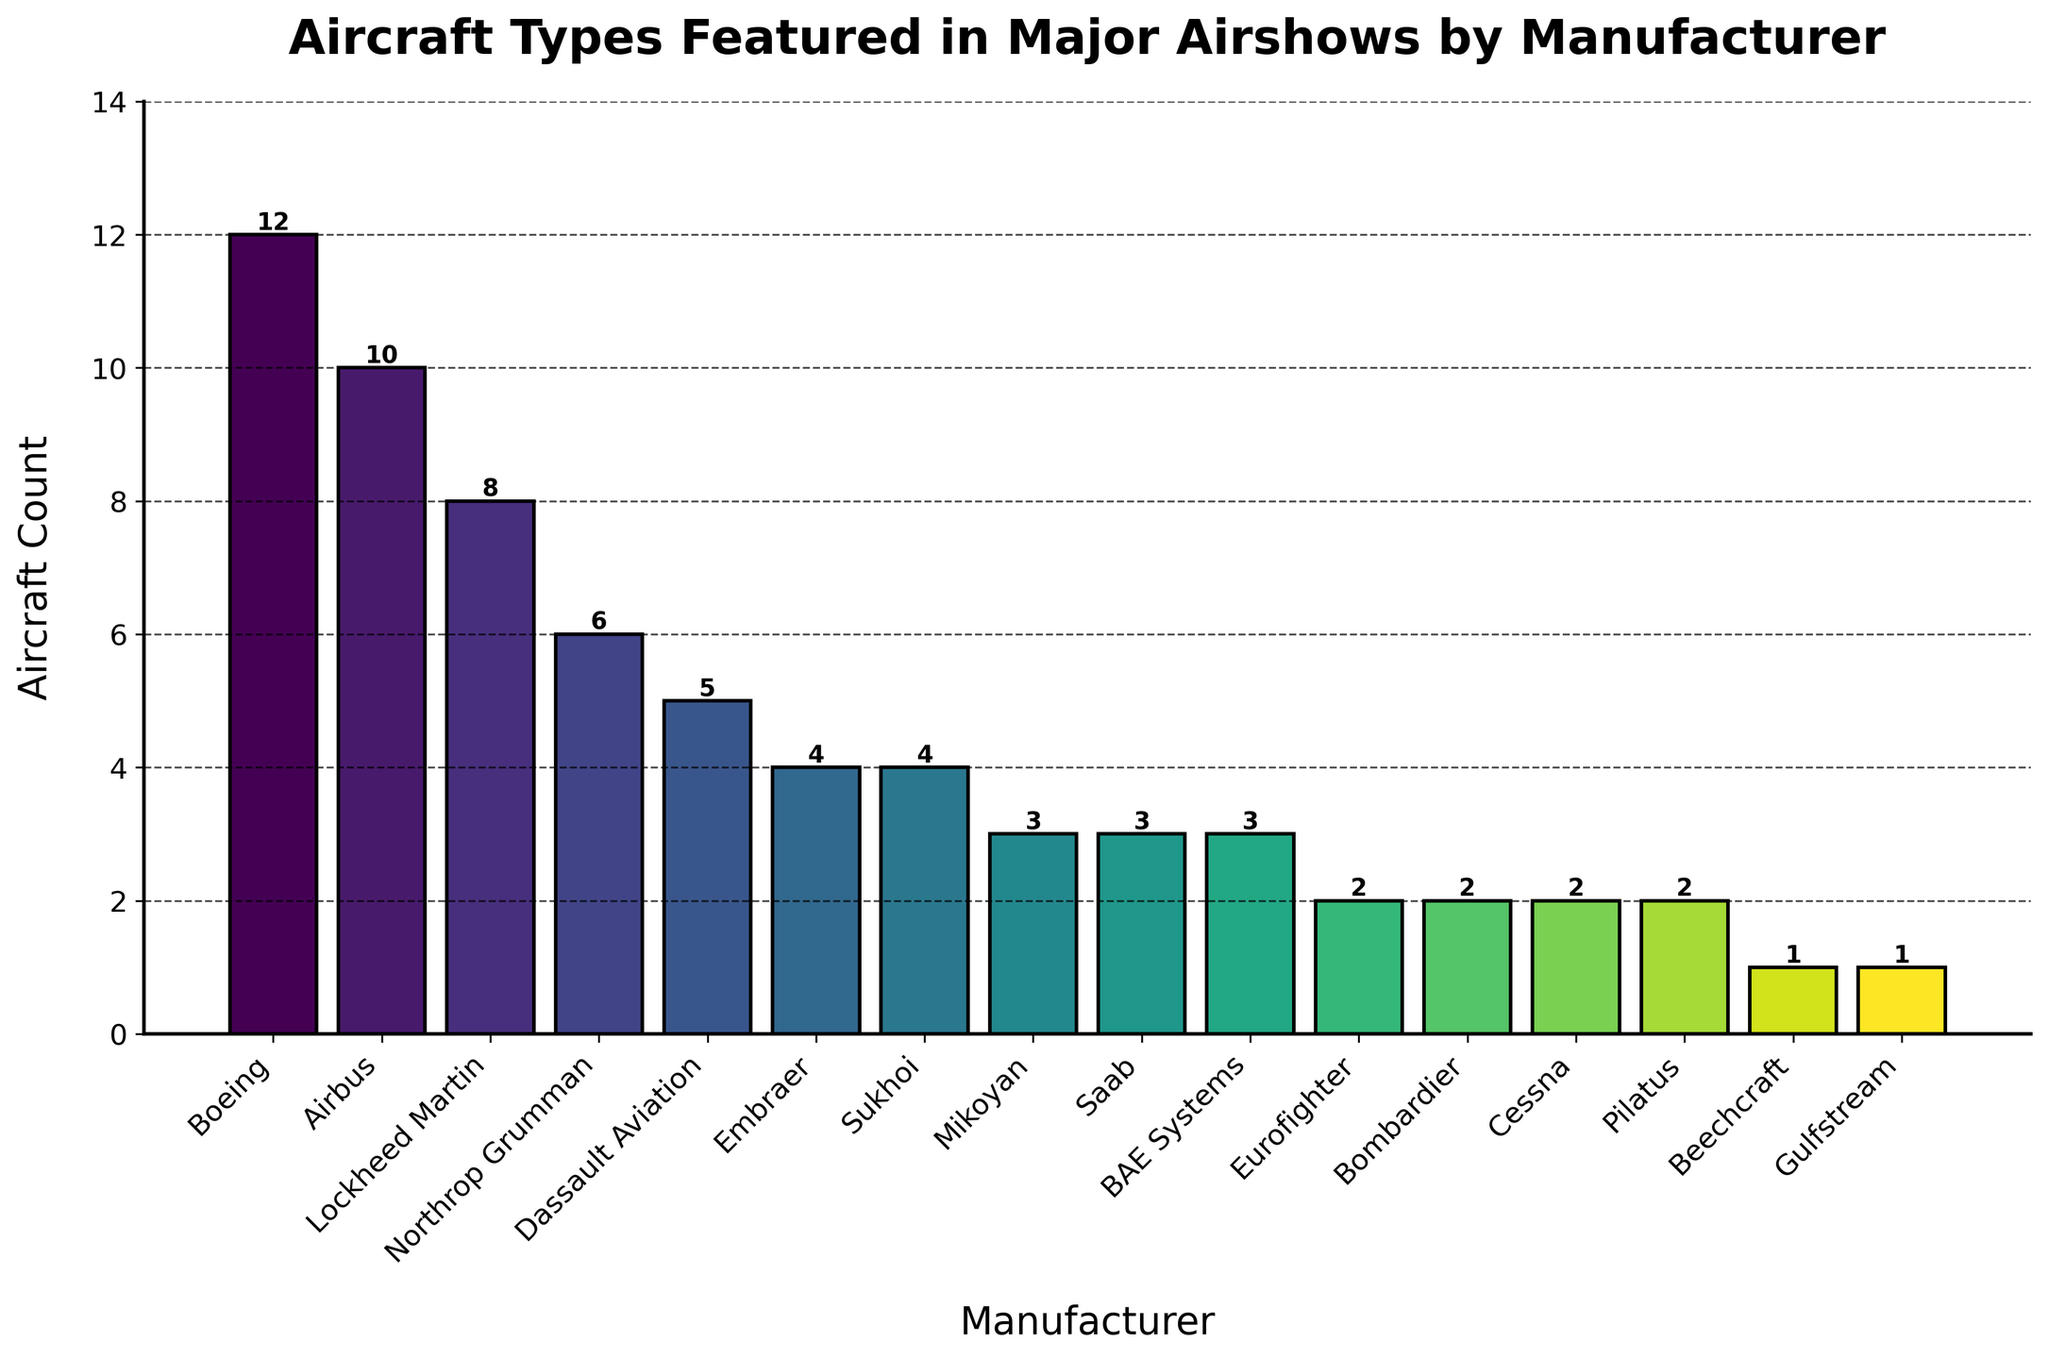Which manufacturer has the highest aircraft count? By examining the height of the bars, it is clear that Boeing has the highest count.
Answer: Boeing How many more aircraft does Boeing have compared to Airbus? The bar for Boeing is at 12, and the bar for Airbus is at 10. Subtracting 10 from 12 gives 2.
Answer: 2 What is the total number of aircraft from Lockheed Martin and Dassault Aviation combined? Adding the heights of the Lockheed Martin bar (8) and Dassault Aviation bar (5) gives 8 + 5 = 13.
Answer: 13 Which manufacturers have an equal aircraft count of 3? The manufacturers with bars at the same height of 3 are Mikoyan, Saab, and BAE Systems.
Answer: Mikoyan, Saab, BAE Systems How many manufacturers feature exactly 2 aircraft? Looking at the bars, the manufacturers with a height of 2 are Eurofighter, Bombardier, Cessna, and Pilatus. Counting these gives 4 manufacturers.
Answer: 4 What's the average aircraft count of all the manufacturers? Adding all the aircraft counts: 12+10+8+6+5+4+4+3+3+3+2+2+2+2+1+1 = 70. Dividing by the number of manufacturers (16) gives an average of 70/16 ≈ 4.38.
Answer: 4.38 By how much does Embraer's count exceed Gulfstream's count? The bar for Embraer shows 4, while the bar for Gulfstream shows 1. Subtracting 1 from 4 gives 3.
Answer: 3 Which manufacturer is represented by a bar colored most similarly to the one for Lockheed Martin? Since colors change gradually, manufacturers close to Lockheed Martin (8) would be Northrop Grumman (6) and Dassault Aviation (5).
Answer: Northrop Grumman, Dassault Aviation How many manufacturers have an aircraft count less than 5? Those with counts Demployment vendedores.sa from the bar heights are: Embraer (4), Sukhoi (4), Mikoyan (3), Saab (3), BAE Systems (3), Eurofighter (2), Bombardier (2), Cessna (2), Pilatus (2), Beechcraft (1), Gulfstream (1). Counting these gives 11 manufacturers.
Answer: 11 What is the difference between the highest and lowest aircraft count? The highest count is Boeing with 12, and the lowest counts are Beechcraft and Gulfstream, each with 1. Subtracting 1 from 12 gives 11.
Answer: 11 